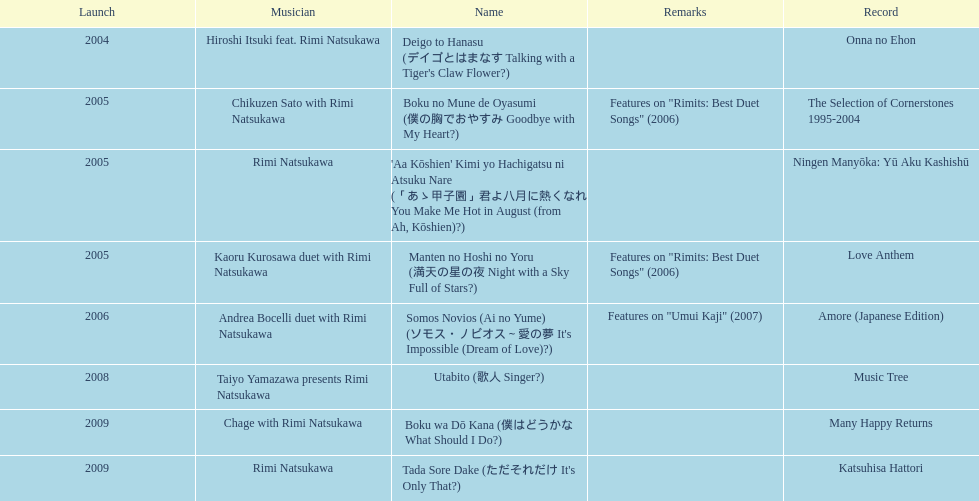What year was the first title released? 2004. 